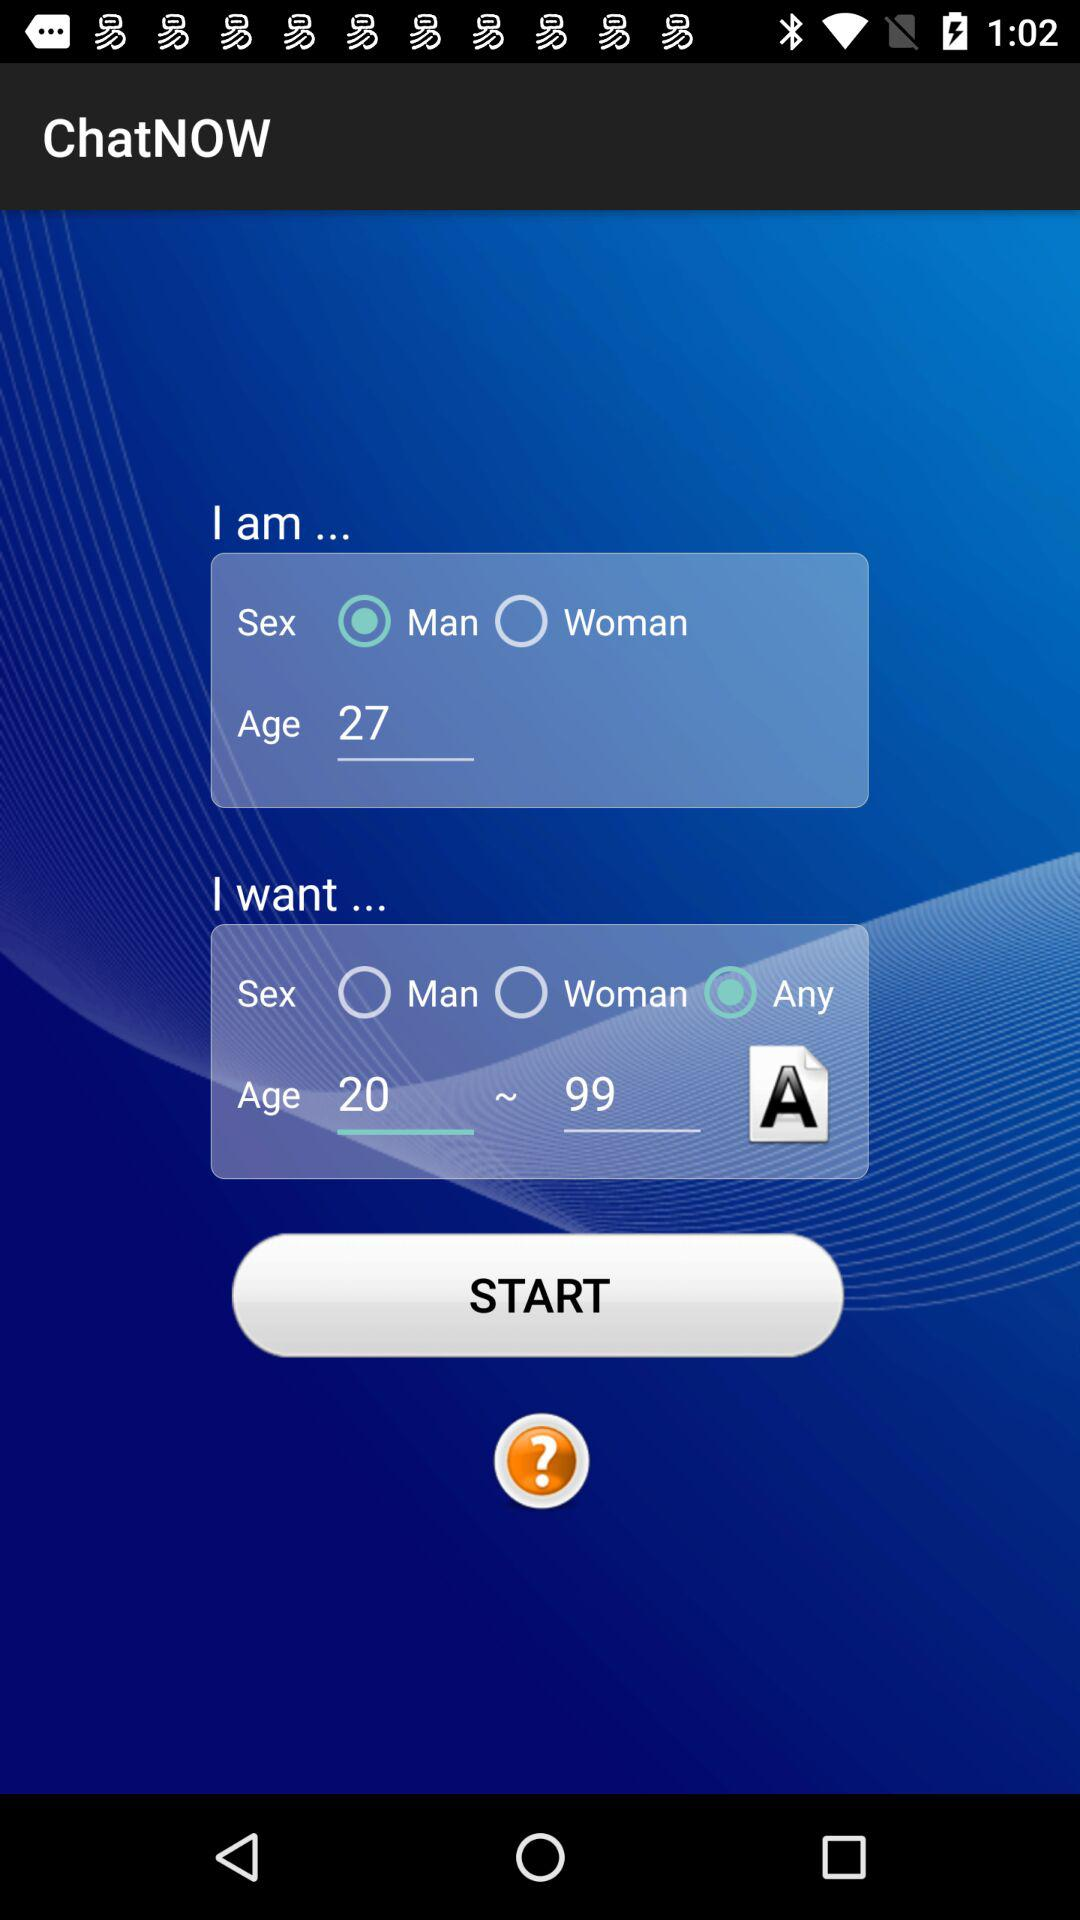Which gender is selected? The selected gender is man. 